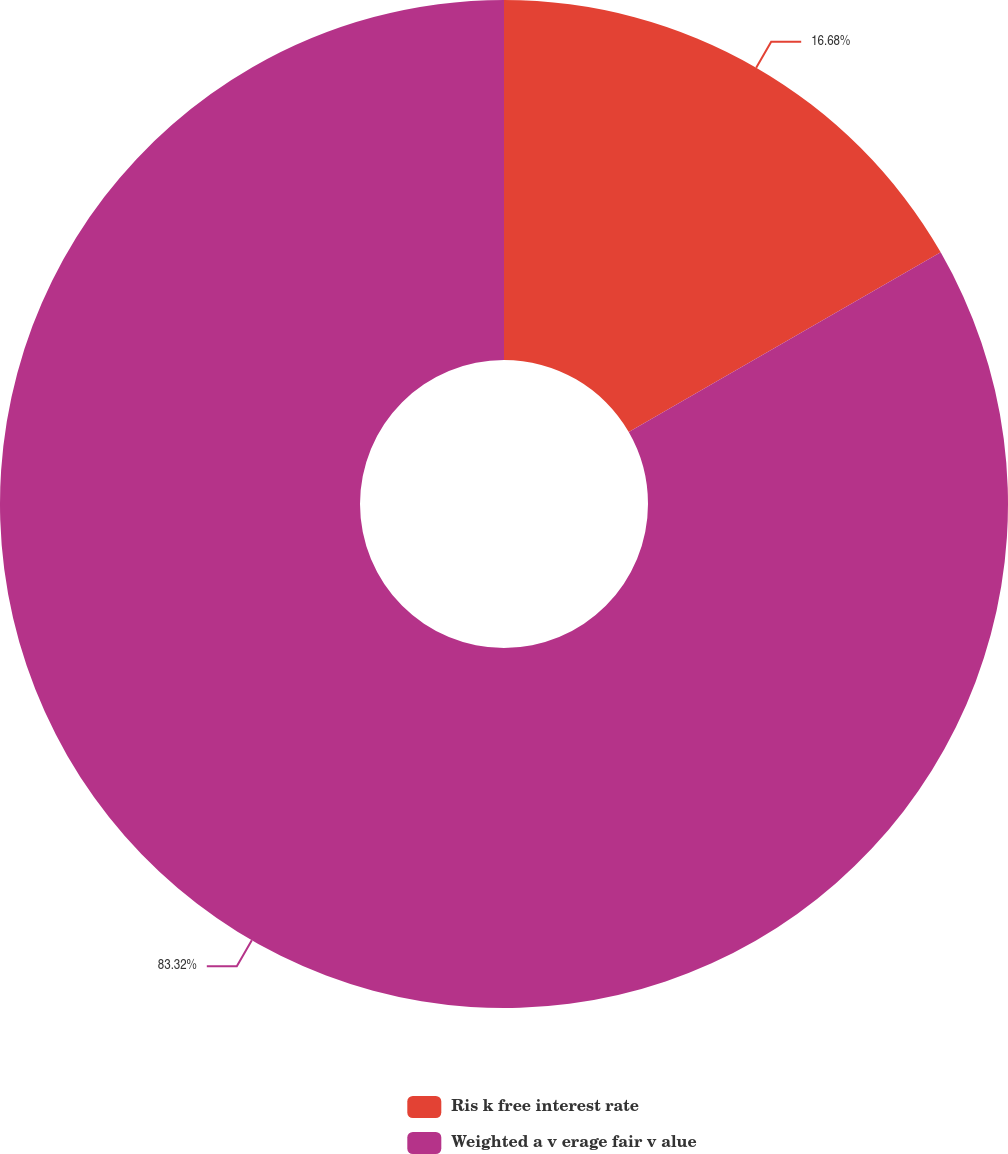Convert chart. <chart><loc_0><loc_0><loc_500><loc_500><pie_chart><fcel>Ris k free interest rate<fcel>Weighted a v erage fair v alue<nl><fcel>16.68%<fcel>83.32%<nl></chart> 